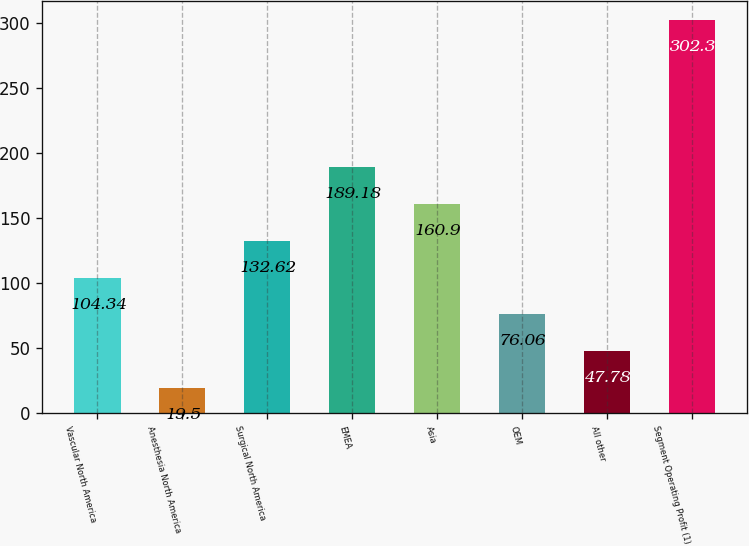<chart> <loc_0><loc_0><loc_500><loc_500><bar_chart><fcel>Vascular North America<fcel>Anesthesia North America<fcel>Surgical North America<fcel>EMEA<fcel>Asia<fcel>OEM<fcel>All other<fcel>Segment Operating Profit (1)<nl><fcel>104.34<fcel>19.5<fcel>132.62<fcel>189.18<fcel>160.9<fcel>76.06<fcel>47.78<fcel>302.3<nl></chart> 